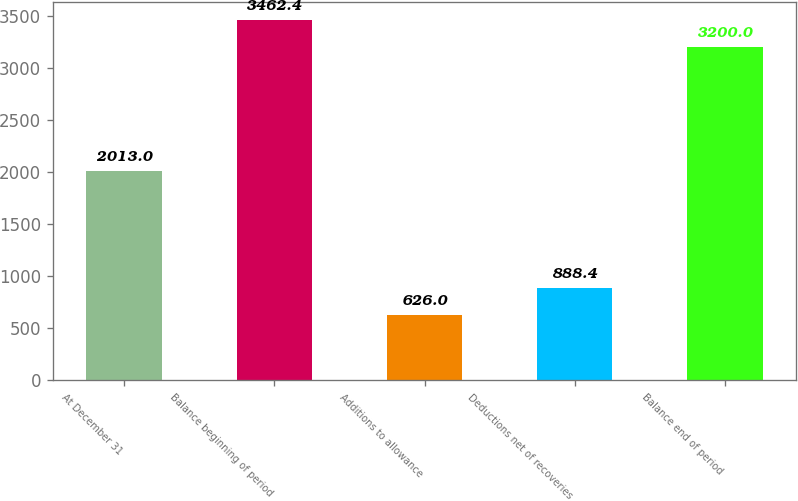<chart> <loc_0><loc_0><loc_500><loc_500><bar_chart><fcel>At December 31<fcel>Balance beginning of period<fcel>Additions to allowance<fcel>Deductions net of recoveries<fcel>Balance end of period<nl><fcel>2013<fcel>3462.4<fcel>626<fcel>888.4<fcel>3200<nl></chart> 